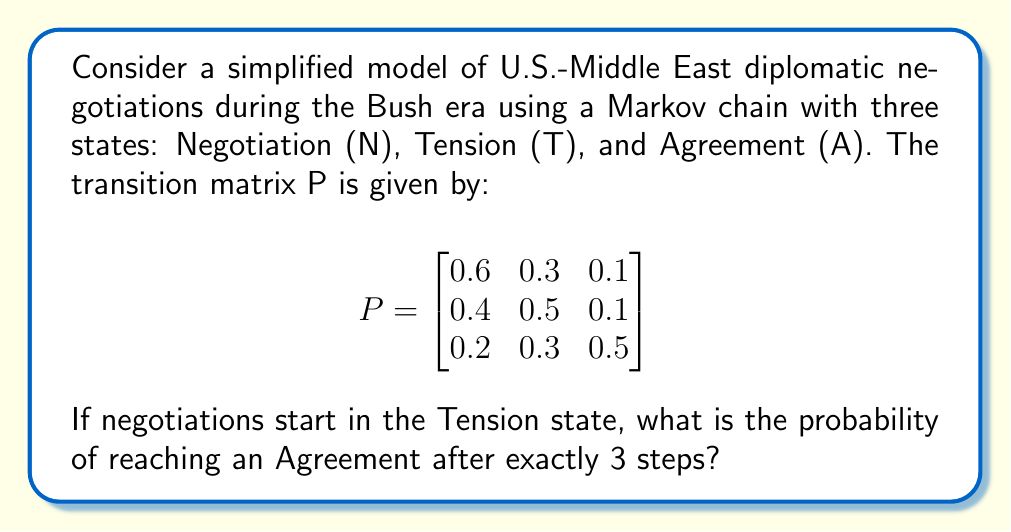Help me with this question. To solve this problem, we'll use the Chapman-Kolmogorov equations and matrix multiplication:

1) The initial state vector is $\mathbf{v}_0 = \begin{bmatrix} 0 & 1 & 0 \end{bmatrix}$, representing the Tension state.

2) We need to calculate $\mathbf{v}_3 = \mathbf{v}_0 P^3$

3) First, let's calculate $P^2$:

   $$ P^2 = \begin{bmatrix}
   0.6 & 0.3 & 0.1 \\
   0.4 & 0.5 & 0.1 \\
   0.2 & 0.3 & 0.5
   \end{bmatrix} \times \begin{bmatrix}
   0.6 & 0.3 & 0.1 \\
   0.4 & 0.5 & 0.1 \\
   0.2 & 0.3 & 0.5
   \end{bmatrix} = \begin{bmatrix}
   0.52 & 0.36 & 0.12 \\
   0.50 & 0.39 & 0.11 \\
   0.38 & 0.39 & 0.23
   \end{bmatrix} $$

4) Now, let's calculate $P^3$:

   $$ P^3 = P^2 \times P = \begin{bmatrix}
   0.52 & 0.36 & 0.12 \\
   0.50 & 0.39 & 0.11 \\
   0.38 & 0.39 & 0.23
   \end{bmatrix} \times \begin{bmatrix}
   0.6 & 0.3 & 0.1 \\
   0.4 & 0.5 & 0.1 \\
   0.2 & 0.3 & 0.5
   \end{bmatrix} = \begin{bmatrix}
   0.488 & 0.378 & 0.134 \\
   0.482 & 0.387 & 0.131 \\
   0.434 & 0.393 & 0.173
   \end{bmatrix} $$

5) Finally, we multiply the initial state vector by $P^3$:

   $\mathbf{v}_3 = \mathbf{v}_0 P^3 = \begin{bmatrix} 0 & 1 & 0 \end{bmatrix} \times \begin{bmatrix}
   0.488 & 0.378 & 0.134 \\
   0.482 & 0.387 & 0.131 \\
   0.434 & 0.393 & 0.173
   \end{bmatrix} = \begin{bmatrix} 0.482 & 0.387 & 0.131 \end{bmatrix}$

6) The probability of reaching an Agreement (the third state) after exactly 3 steps is 0.131 or 13.1%.
Answer: 0.131 